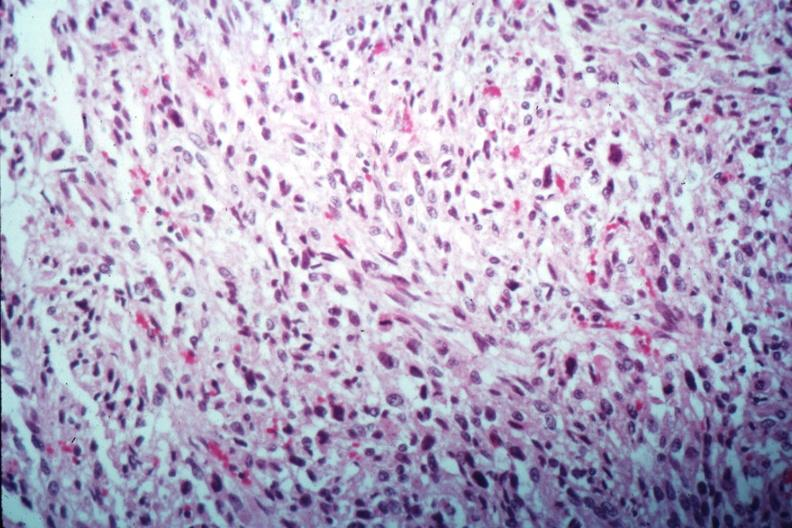what is present?
Answer the question using a single word or phrase. Uterus 